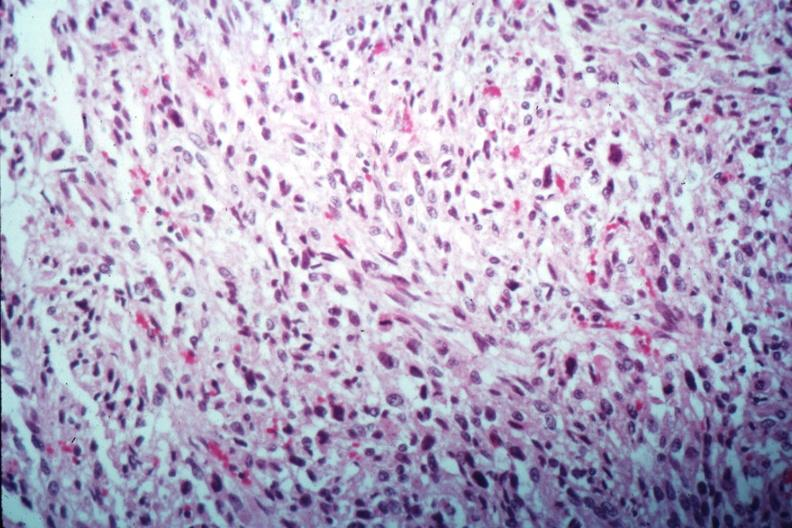what is present?
Answer the question using a single word or phrase. Uterus 